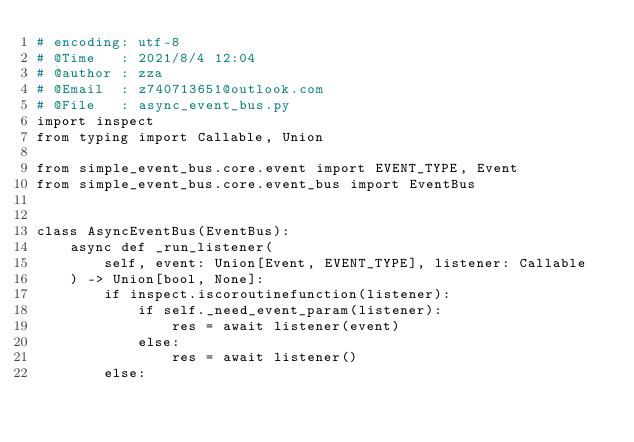Convert code to text. <code><loc_0><loc_0><loc_500><loc_500><_Python_># encoding: utf-8
# @Time   : 2021/8/4 12:04
# @author : zza
# @Email  : z740713651@outlook.com
# @File   : async_event_bus.py
import inspect
from typing import Callable, Union

from simple_event_bus.core.event import EVENT_TYPE, Event
from simple_event_bus.core.event_bus import EventBus


class AsyncEventBus(EventBus):
    async def _run_listener(
        self, event: Union[Event, EVENT_TYPE], listener: Callable
    ) -> Union[bool, None]:
        if inspect.iscoroutinefunction(listener):
            if self._need_event_param(listener):
                res = await listener(event)
            else:
                res = await listener()
        else:</code> 